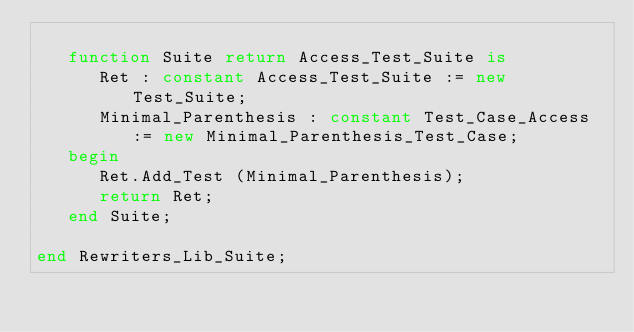<code> <loc_0><loc_0><loc_500><loc_500><_Ada_>
   function Suite return Access_Test_Suite is
      Ret : constant Access_Test_Suite := new Test_Suite;
      Minimal_Parenthesis : constant Test_Case_Access := new Minimal_Parenthesis_Test_Case;
   begin
      Ret.Add_Test (Minimal_Parenthesis);
      return Ret;
   end Suite;

end Rewriters_Lib_Suite;
</code> 